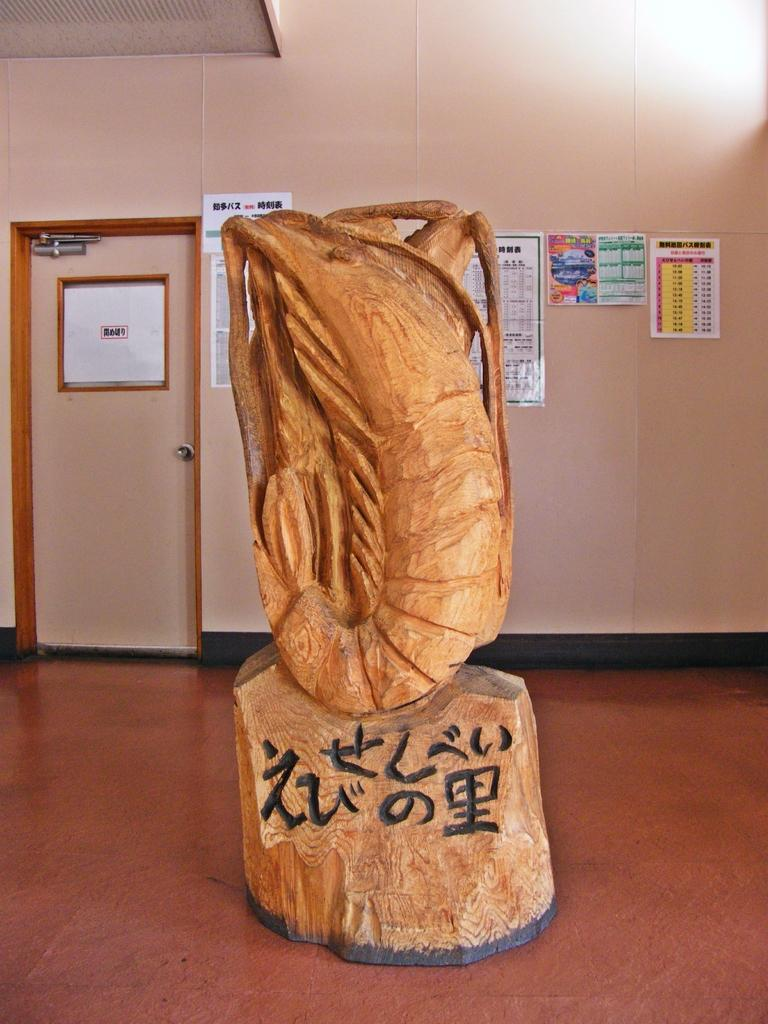<image>
Give a short and clear explanation of the subsequent image. A large wood carving statue of a shrimp with Asian symbols and lettering at its base. 